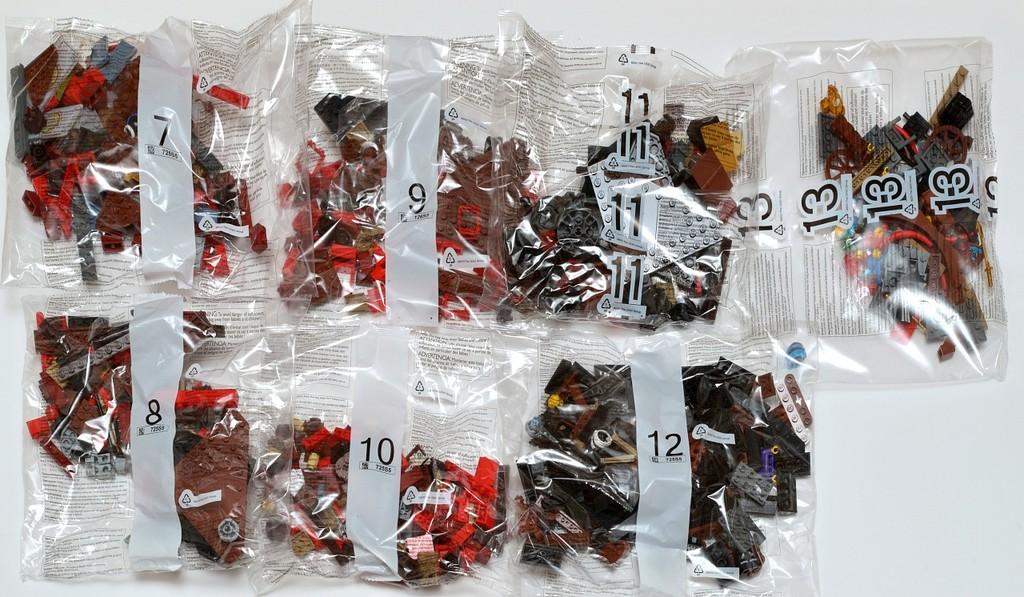What objects are present in the image? There are toys in the image. How are the toys packaged? The toys are in packets. How are the packets arranged? The packets are arranged on a surface. What color is the background of the image? The background of the image is white. What type of metal is used to create the beast in the image? There is no beast present in the image, and therefore no metal can be associated with it. 